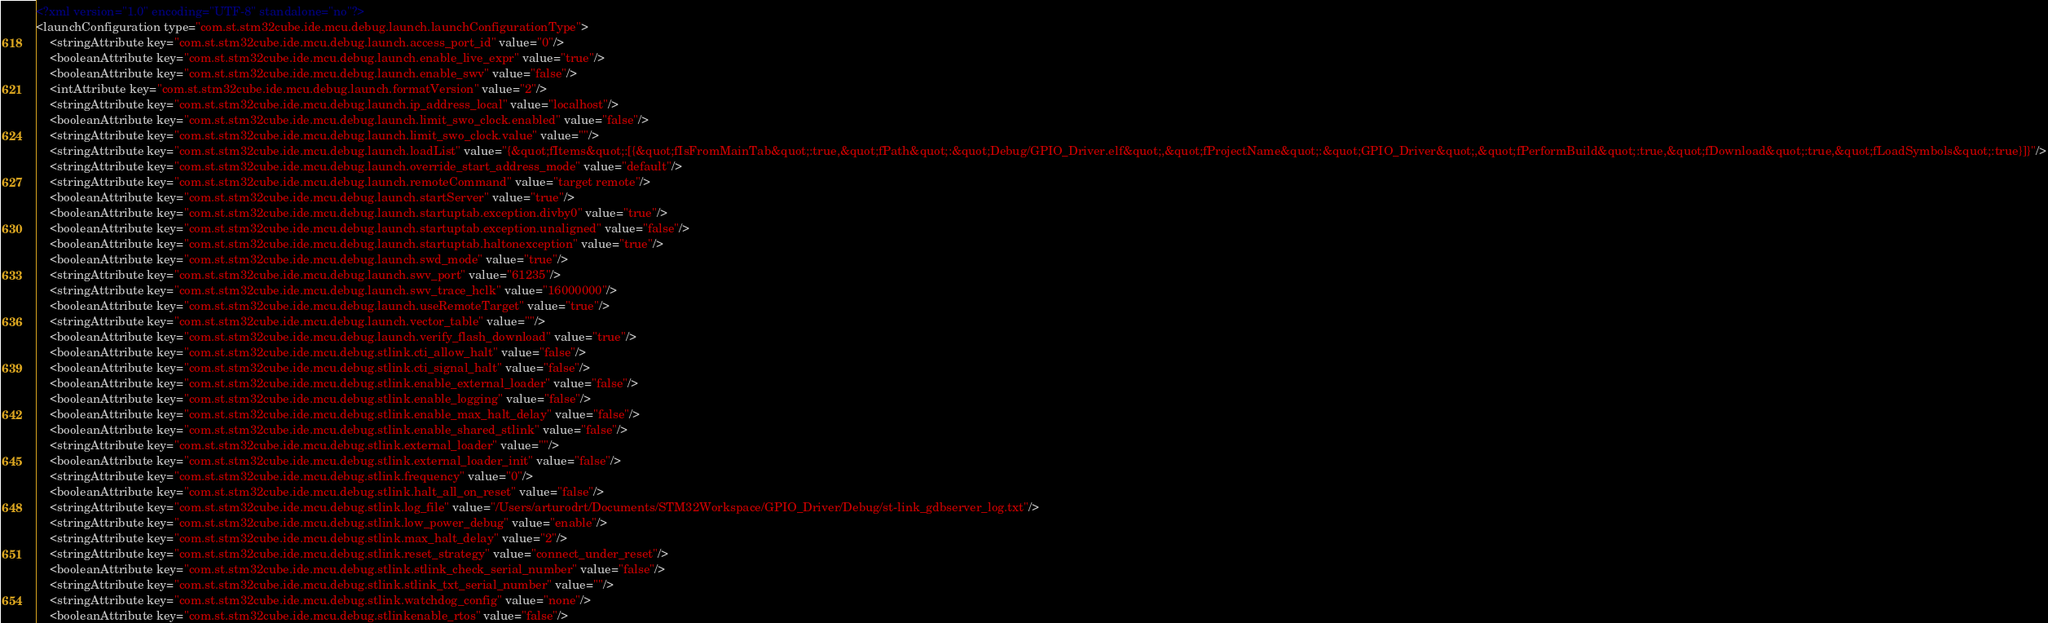<code> <loc_0><loc_0><loc_500><loc_500><_XML_><?xml version="1.0" encoding="UTF-8" standalone="no"?>
<launchConfiguration type="com.st.stm32cube.ide.mcu.debug.launch.launchConfigurationType">
    <stringAttribute key="com.st.stm32cube.ide.mcu.debug.launch.access_port_id" value="0"/>
    <booleanAttribute key="com.st.stm32cube.ide.mcu.debug.launch.enable_live_expr" value="true"/>
    <booleanAttribute key="com.st.stm32cube.ide.mcu.debug.launch.enable_swv" value="false"/>
    <intAttribute key="com.st.stm32cube.ide.mcu.debug.launch.formatVersion" value="2"/>
    <stringAttribute key="com.st.stm32cube.ide.mcu.debug.launch.ip_address_local" value="localhost"/>
    <booleanAttribute key="com.st.stm32cube.ide.mcu.debug.launch.limit_swo_clock.enabled" value="false"/>
    <stringAttribute key="com.st.stm32cube.ide.mcu.debug.launch.limit_swo_clock.value" value=""/>
    <stringAttribute key="com.st.stm32cube.ide.mcu.debug.launch.loadList" value="{&quot;fItems&quot;:[{&quot;fIsFromMainTab&quot;:true,&quot;fPath&quot;:&quot;Debug/GPIO_Driver.elf&quot;,&quot;fProjectName&quot;:&quot;GPIO_Driver&quot;,&quot;fPerformBuild&quot;:true,&quot;fDownload&quot;:true,&quot;fLoadSymbols&quot;:true}]}"/>
    <stringAttribute key="com.st.stm32cube.ide.mcu.debug.launch.override_start_address_mode" value="default"/>
    <stringAttribute key="com.st.stm32cube.ide.mcu.debug.launch.remoteCommand" value="target remote"/>
    <booleanAttribute key="com.st.stm32cube.ide.mcu.debug.launch.startServer" value="true"/>
    <booleanAttribute key="com.st.stm32cube.ide.mcu.debug.launch.startuptab.exception.divby0" value="true"/>
    <booleanAttribute key="com.st.stm32cube.ide.mcu.debug.launch.startuptab.exception.unaligned" value="false"/>
    <booleanAttribute key="com.st.stm32cube.ide.mcu.debug.launch.startuptab.haltonexception" value="true"/>
    <booleanAttribute key="com.st.stm32cube.ide.mcu.debug.launch.swd_mode" value="true"/>
    <stringAttribute key="com.st.stm32cube.ide.mcu.debug.launch.swv_port" value="61235"/>
    <stringAttribute key="com.st.stm32cube.ide.mcu.debug.launch.swv_trace_hclk" value="16000000"/>
    <booleanAttribute key="com.st.stm32cube.ide.mcu.debug.launch.useRemoteTarget" value="true"/>
    <stringAttribute key="com.st.stm32cube.ide.mcu.debug.launch.vector_table" value=""/>
    <booleanAttribute key="com.st.stm32cube.ide.mcu.debug.launch.verify_flash_download" value="true"/>
    <booleanAttribute key="com.st.stm32cube.ide.mcu.debug.stlink.cti_allow_halt" value="false"/>
    <booleanAttribute key="com.st.stm32cube.ide.mcu.debug.stlink.cti_signal_halt" value="false"/>
    <booleanAttribute key="com.st.stm32cube.ide.mcu.debug.stlink.enable_external_loader" value="false"/>
    <booleanAttribute key="com.st.stm32cube.ide.mcu.debug.stlink.enable_logging" value="false"/>
    <booleanAttribute key="com.st.stm32cube.ide.mcu.debug.stlink.enable_max_halt_delay" value="false"/>
    <booleanAttribute key="com.st.stm32cube.ide.mcu.debug.stlink.enable_shared_stlink" value="false"/>
    <stringAttribute key="com.st.stm32cube.ide.mcu.debug.stlink.external_loader" value=""/>
    <booleanAttribute key="com.st.stm32cube.ide.mcu.debug.stlink.external_loader_init" value="false"/>
    <stringAttribute key="com.st.stm32cube.ide.mcu.debug.stlink.frequency" value="0"/>
    <booleanAttribute key="com.st.stm32cube.ide.mcu.debug.stlink.halt_all_on_reset" value="false"/>
    <stringAttribute key="com.st.stm32cube.ide.mcu.debug.stlink.log_file" value="/Users/arturodrt/Documents/STM32Workspace/GPIO_Driver/Debug/st-link_gdbserver_log.txt"/>
    <stringAttribute key="com.st.stm32cube.ide.mcu.debug.stlink.low_power_debug" value="enable"/>
    <stringAttribute key="com.st.stm32cube.ide.mcu.debug.stlink.max_halt_delay" value="2"/>
    <stringAttribute key="com.st.stm32cube.ide.mcu.debug.stlink.reset_strategy" value="connect_under_reset"/>
    <booleanAttribute key="com.st.stm32cube.ide.mcu.debug.stlink.stlink_check_serial_number" value="false"/>
    <stringAttribute key="com.st.stm32cube.ide.mcu.debug.stlink.stlink_txt_serial_number" value=""/>
    <stringAttribute key="com.st.stm32cube.ide.mcu.debug.stlink.watchdog_config" value="none"/>
    <booleanAttribute key="com.st.stm32cube.ide.mcu.debug.stlinkenable_rtos" value="false"/></code> 